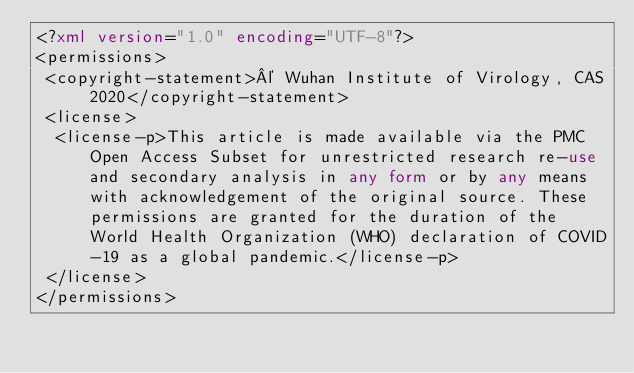Convert code to text. <code><loc_0><loc_0><loc_500><loc_500><_XML_><?xml version="1.0" encoding="UTF-8"?>
<permissions>
 <copyright-statement>© Wuhan Institute of Virology, CAS 2020</copyright-statement>
 <license>
  <license-p>This article is made available via the PMC Open Access Subset for unrestricted research re-use and secondary analysis in any form or by any means with acknowledgement of the original source. These permissions are granted for the duration of the World Health Organization (WHO) declaration of COVID-19 as a global pandemic.</license-p>
 </license>
</permissions>
</code> 